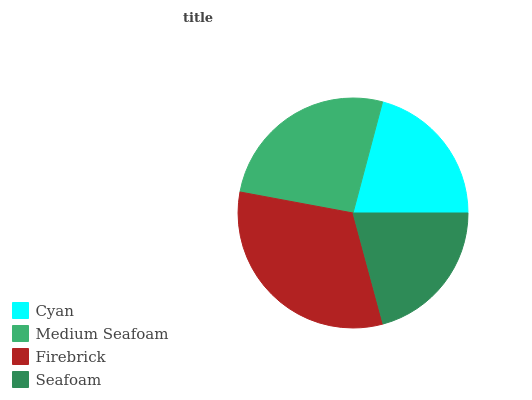Is Seafoam the minimum?
Answer yes or no. Yes. Is Firebrick the maximum?
Answer yes or no. Yes. Is Medium Seafoam the minimum?
Answer yes or no. No. Is Medium Seafoam the maximum?
Answer yes or no. No. Is Medium Seafoam greater than Cyan?
Answer yes or no. Yes. Is Cyan less than Medium Seafoam?
Answer yes or no. Yes. Is Cyan greater than Medium Seafoam?
Answer yes or no. No. Is Medium Seafoam less than Cyan?
Answer yes or no. No. Is Medium Seafoam the high median?
Answer yes or no. Yes. Is Cyan the low median?
Answer yes or no. Yes. Is Firebrick the high median?
Answer yes or no. No. Is Medium Seafoam the low median?
Answer yes or no. No. 